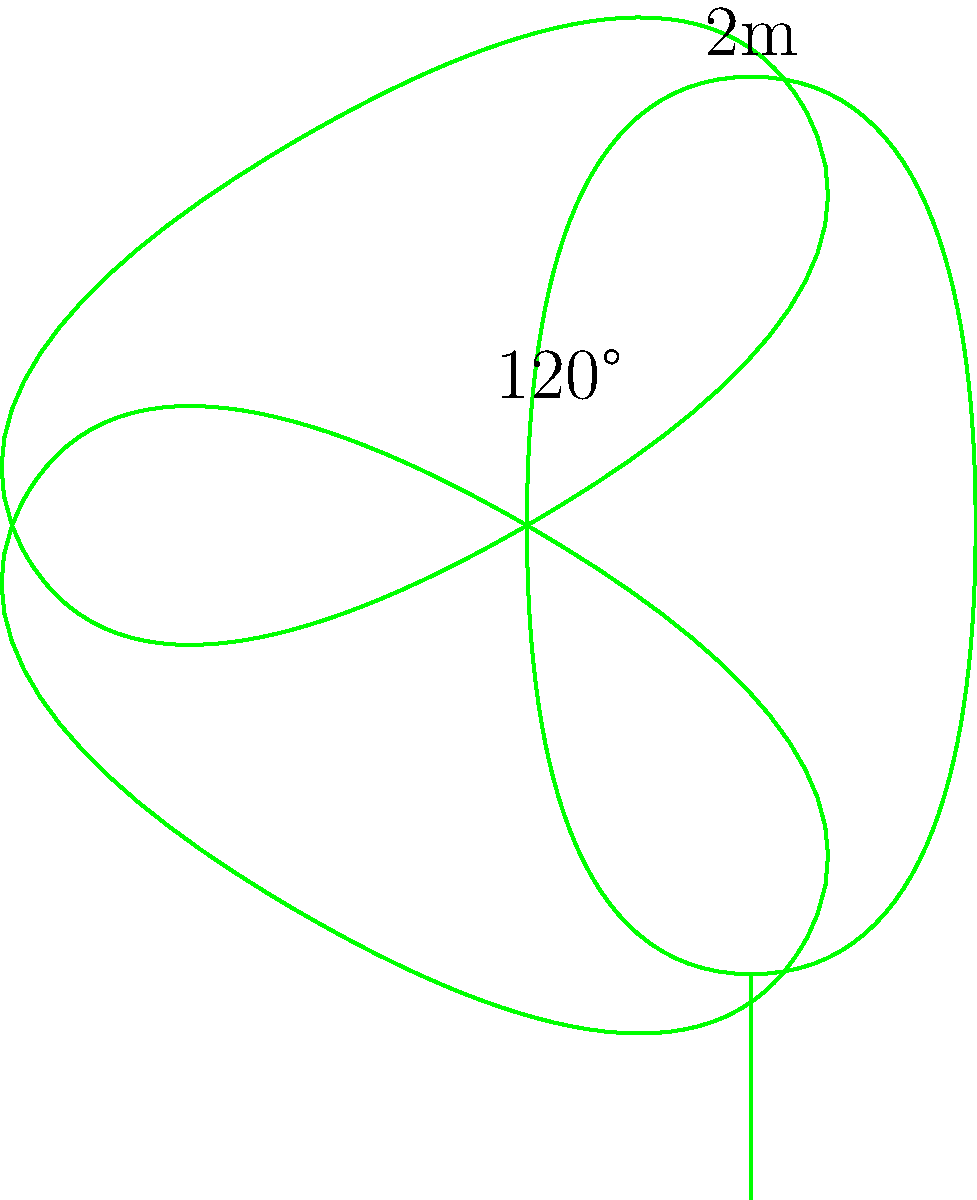As a filmmaker exploring Irish traditions, you're designing a shamrock-shaped garden plot for a documentary set. The plot consists of three identical curved leaves arranged symmetrically, with each leaf measuring 2 meters at its widest point. The angle between any two adjacent leaves is 120°. Assuming each leaf can be approximated as a circular sector, calculate the total area of the shamrock-shaped garden plot in square meters. Round your answer to two decimal places. To solve this problem, let's break it down into steps:

1) First, we need to calculate the area of one leaf. Each leaf can be approximated as a circular sector.

2) For a circular sector, we need to know its radius and central angle. We're given that the widest point (diameter) is 2m, so the radius is 1m.

3) The central angle of each leaf can be calculated as follows:
   - The angle between leaves is 120°
   - Therefore, the angle each leaf occupies is 360° - 120° = 240°

4) The area of a circular sector is given by the formula:
   $A = \frac{1}{2}r^2\theta$
   Where $r$ is the radius and $\theta$ is the central angle in radians.

5) We need to convert 240° to radians:
   $240° * \frac{\pi}{180°} = \frac{4\pi}{3}$ radians

6) Now we can calculate the area of one leaf:
   $A = \frac{1}{2} * 1^2 * \frac{4\pi}{3} = \frac{2\pi}{3}$ m²

7) The total area of the shamrock is three times this:
   $A_{total} = 3 * \frac{2\pi}{3} = 2\pi$ m²

8) Calculating this and rounding to two decimal places:
   $2\pi \approx 6.28$ m²
Answer: 6.28 m² 